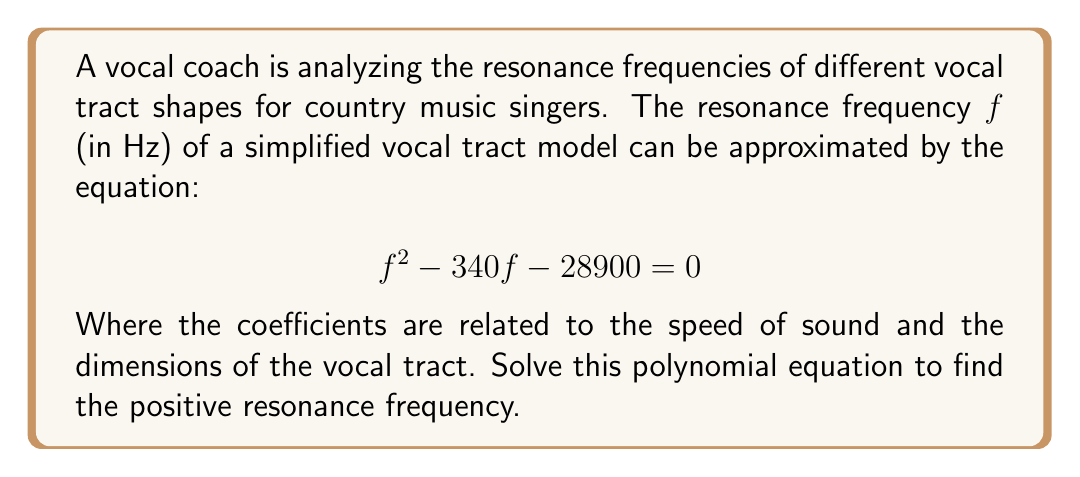Could you help me with this problem? To solve this quadratic equation, we'll use the quadratic formula:

$$x = \frac{-b \pm \sqrt{b^2 - 4ac}}{2a}$$

Where $a = 1$, $b = -340$, and $c = -28900$

1) Substitute these values into the quadratic formula:

   $$f = \frac{340 \pm \sqrt{(-340)^2 - 4(1)(-28900)}}{2(1)}$$

2) Simplify under the square root:

   $$f = \frac{340 \pm \sqrt{115600 + 115600}}{2} = \frac{340 \pm \sqrt{231200}}{2}$$

3) Simplify the square root:

   $$f = \frac{340 \pm 480.83}{2}$$

4) Calculate both possible solutions:

   $$f_1 = \frac{340 + 480.83}{2} \approx 410.42$$
   $$f_2 = \frac{340 - 480.83}{2} \approx -70.42$$

5) Since frequency cannot be negative, we choose the positive solution.

Therefore, the positive resonance frequency is approximately 410.42 Hz.
Answer: $410.42$ Hz 